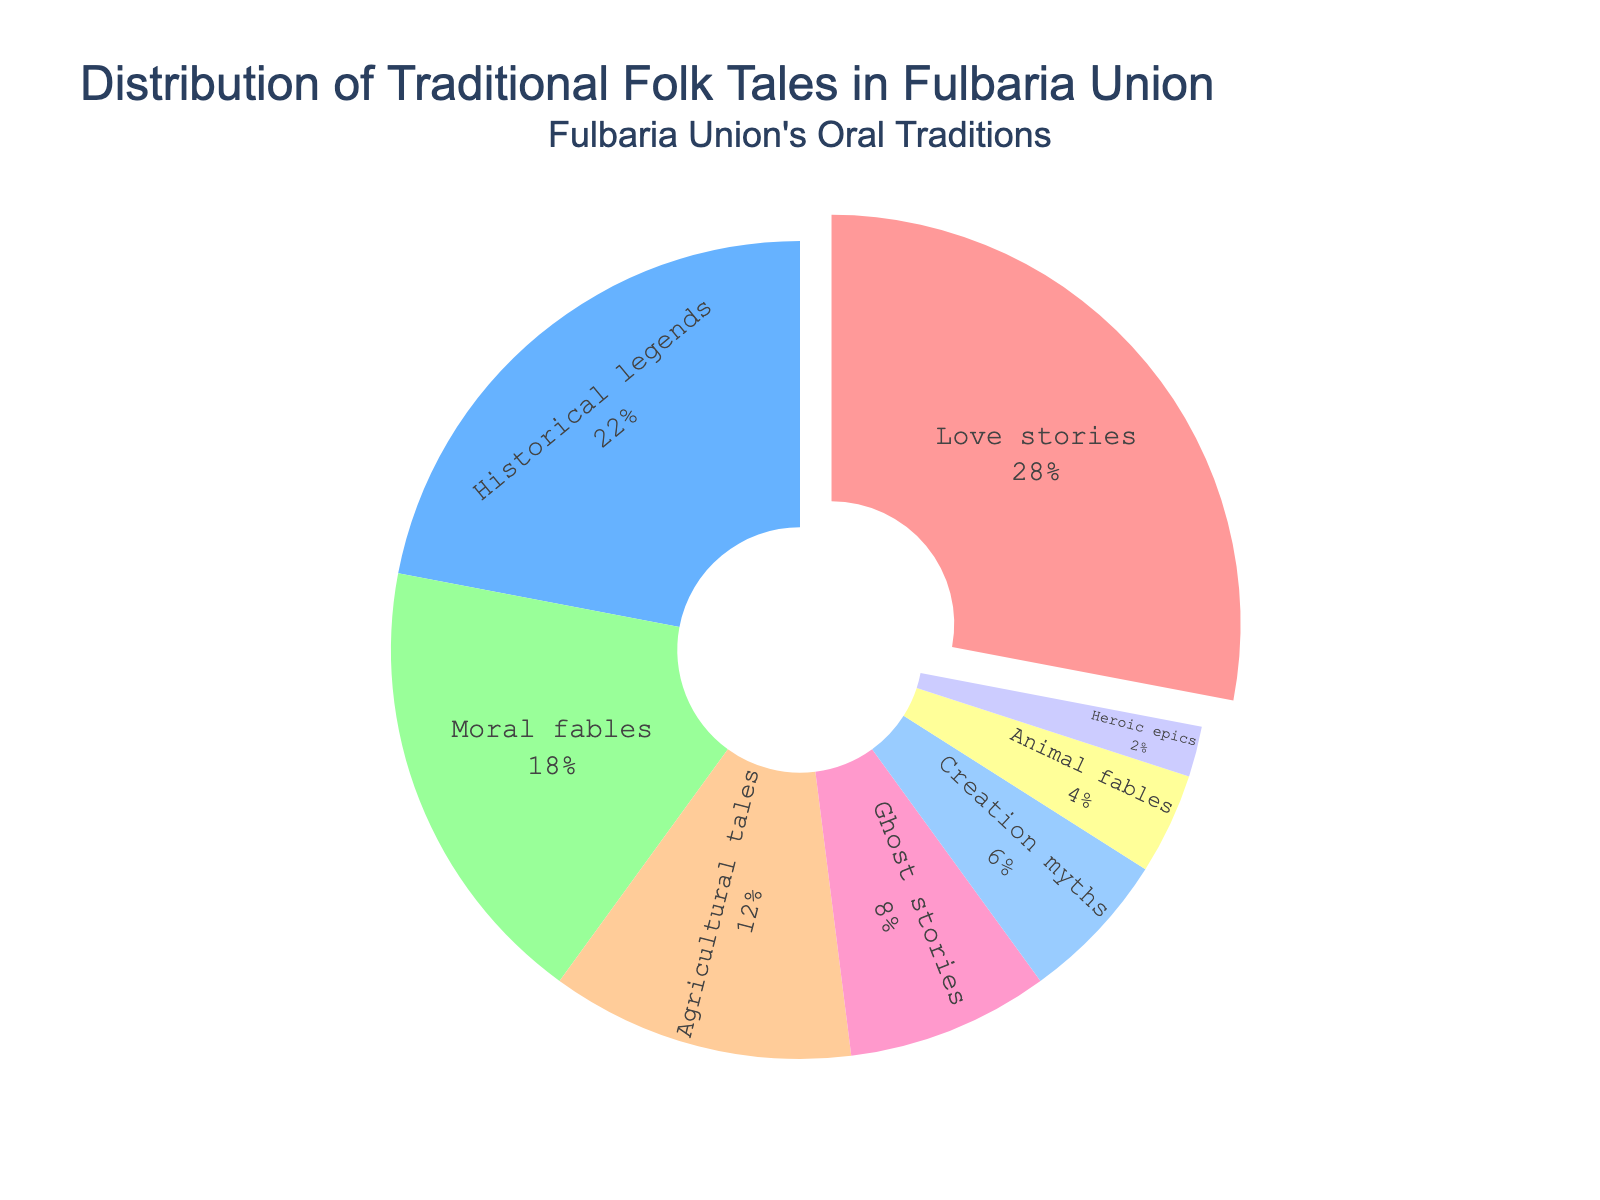What is the most common theme among traditional folk tales in Fulbaria Union? The plot shows various themes with their corresponding percentages. The theme with the highest percentage is 'Love stories' with 28%.
Answer: Love stories Which theme has the lowest percentage among traditional folk tales in Fulbaria Union? The plot shows various themes with their corresponding percentages. The theme with the lowest percentage is 'Heroic epics' with 2%.
Answer: Heroic epics What is the combined percentage of 'Historical legends' and 'Moral fables'? The plot shows percentages for each theme. 'Historical legends' has 22% and 'Moral fables' has 18%. Adding these gives 22% + 18% = 40%.
Answer: 40% Is the percentage of 'Agricultural tales' higher than 'Ghost stories'? The plot shows 'Agricultural tales' with 12% and 'Ghost stories' with 8%. Since 12% > 8%, the percentage of 'Agricultural tales' is higher.
Answer: Yes How much greater is the percentage of 'Love stories' compared to 'Creation myths'? The plot shows 'Love stories' with 28% and 'Creation myths' with 6%. Subtracting these gives 28% - 6% = 22%.
Answer: 22% What themes together make up exactly half (50%) of the folk tales? Summing the percentages of different theme groups: 'Love stories' (28%) + 'Historical legends' (22%) = 50%. Therefore, these two themes together make up exactly half.
Answer: Love stories and Historical legends Is the percentage of 'Animal fables' the same as 'Heroic epics'? The plot shows 'Animal fables' with 4% and 'Heroic epics' with 2%. Since 4% ≠ 2%, their percentages are not the same.
Answer: No What is the combined percentage of 'Creation myths' and 'Animal fables'? The plot shows 'Creation myths' with 6% and 'Animal fables' with 4%. Adding these gives 6% + 4% = 10%.
Answer: 10% Are there more 'Ghost stories' or 'Animal fables'? The plot shows 'Ghost stories' with 8% and 'Animal fables' with 4%. Since 8% > 4%, there are more 'Ghost stories'.
Answer: Ghost stories What are the three least common themes among traditional folk tales in Fulbaria Union? The plot shows the percentages for each theme: 'Heroic epics' (2%), 'Animal fables' (4%), and 'Creation myths' (6%). These are the three least common themes.
Answer: Heroic epics, Animal fables, and Creation myths 